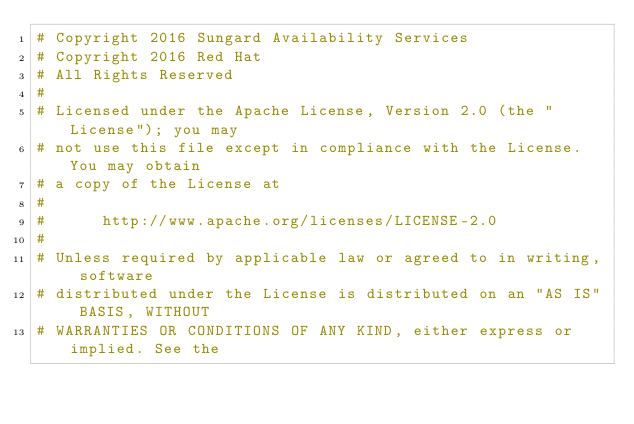<code> <loc_0><loc_0><loc_500><loc_500><_Python_># Copyright 2016 Sungard Availability Services
# Copyright 2016 Red Hat
# All Rights Reserved
#
# Licensed under the Apache License, Version 2.0 (the "License"); you may
# not use this file except in compliance with the License. You may obtain
# a copy of the License at
#
#      http://www.apache.org/licenses/LICENSE-2.0
#
# Unless required by applicable law or agreed to in writing, software
# distributed under the License is distributed on an "AS IS" BASIS, WITHOUT
# WARRANTIES OR CONDITIONS OF ANY KIND, either express or implied. See the</code> 